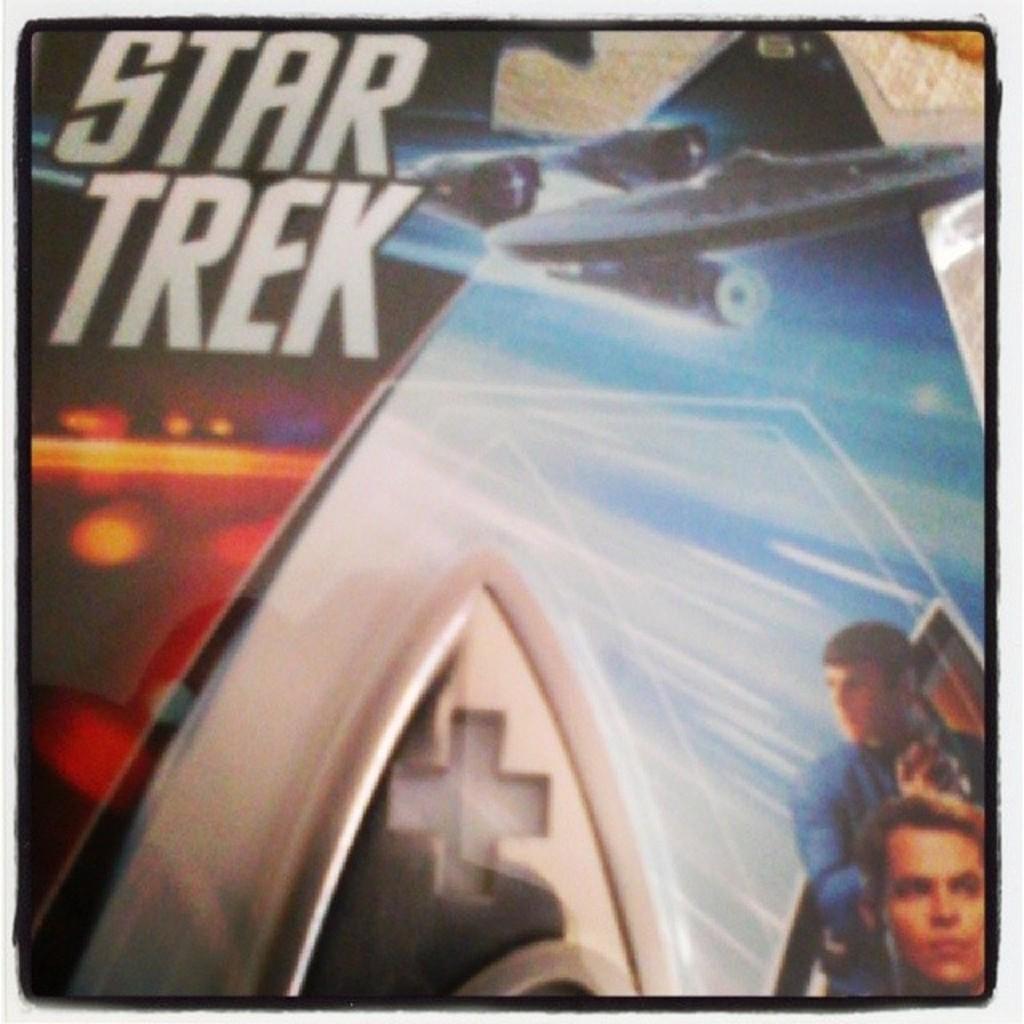Could you give a brief overview of what you see in this image? In the picture we can see a poster with a name on it star trek and image of two men under it. 